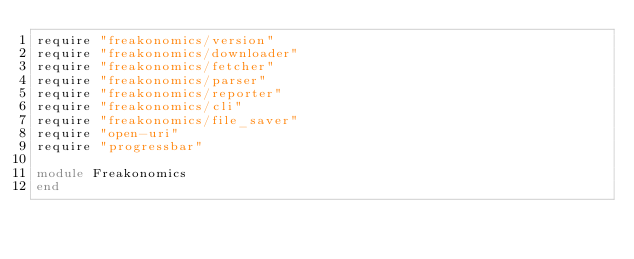Convert code to text. <code><loc_0><loc_0><loc_500><loc_500><_Ruby_>require "freakonomics/version"
require "freakonomics/downloader"
require "freakonomics/fetcher"
require "freakonomics/parser"
require "freakonomics/reporter"
require "freakonomics/cli"
require "freakonomics/file_saver"
require "open-uri"
require "progressbar"

module Freakonomics
end
</code> 